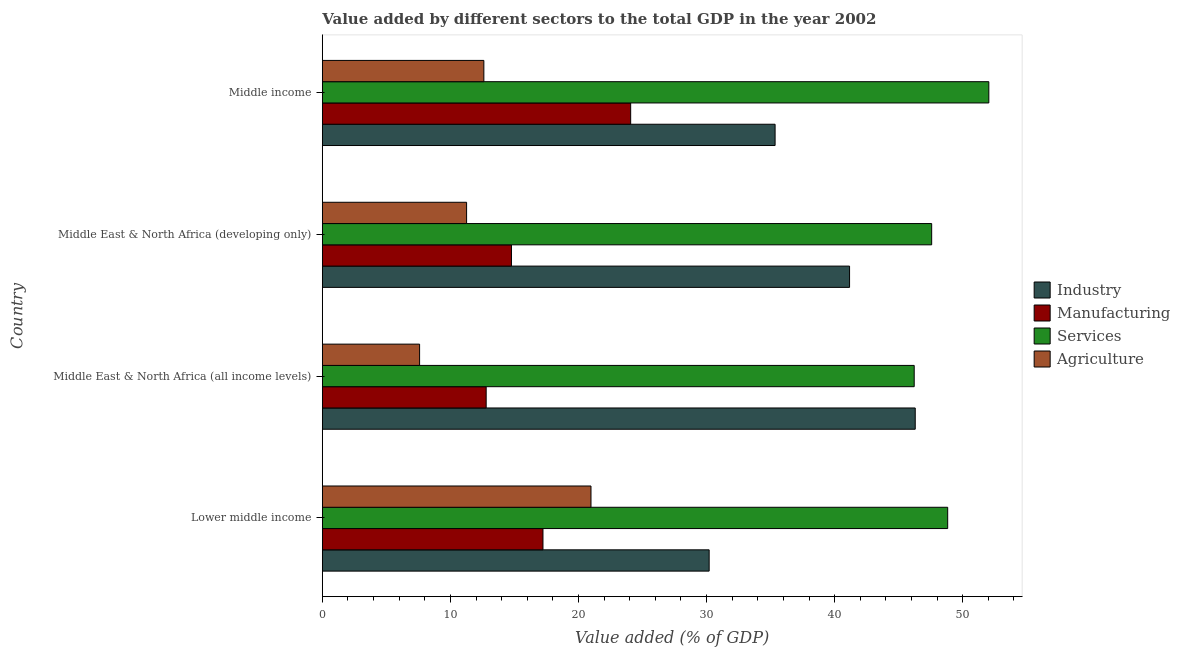How many different coloured bars are there?
Your answer should be very brief. 4. Are the number of bars per tick equal to the number of legend labels?
Offer a terse response. Yes. Are the number of bars on each tick of the Y-axis equal?
Offer a terse response. Yes. What is the label of the 4th group of bars from the top?
Ensure brevity in your answer.  Lower middle income. What is the value added by services sector in Middle income?
Offer a very short reply. 52.04. Across all countries, what is the maximum value added by agricultural sector?
Provide a short and direct response. 20.98. Across all countries, what is the minimum value added by industrial sector?
Provide a succinct answer. 30.2. In which country was the value added by agricultural sector maximum?
Offer a very short reply. Lower middle income. In which country was the value added by services sector minimum?
Keep it short and to the point. Middle East & North Africa (all income levels). What is the total value added by agricultural sector in the graph?
Your answer should be very brief. 52.44. What is the difference between the value added by agricultural sector in Lower middle income and that in Middle East & North Africa (developing only)?
Offer a terse response. 9.71. What is the difference between the value added by industrial sector in Middle East & North Africa (all income levels) and the value added by services sector in Lower middle income?
Make the answer very short. -2.53. What is the average value added by manufacturing sector per country?
Ensure brevity in your answer.  17.21. What is the difference between the value added by industrial sector and value added by services sector in Middle income?
Make the answer very short. -16.69. What is the ratio of the value added by services sector in Middle East & North Africa (all income levels) to that in Middle income?
Your answer should be compact. 0.89. What is the difference between the highest and the second highest value added by services sector?
Your answer should be compact. 3.21. What is the difference between the highest and the lowest value added by industrial sector?
Provide a succinct answer. 16.09. In how many countries, is the value added by manufacturing sector greater than the average value added by manufacturing sector taken over all countries?
Give a very brief answer. 2. Is the sum of the value added by agricultural sector in Middle East & North Africa (all income levels) and Middle income greater than the maximum value added by industrial sector across all countries?
Make the answer very short. No. Is it the case that in every country, the sum of the value added by manufacturing sector and value added by agricultural sector is greater than the sum of value added by industrial sector and value added by services sector?
Provide a succinct answer. No. What does the 2nd bar from the top in Middle East & North Africa (developing only) represents?
Ensure brevity in your answer.  Services. What does the 3rd bar from the bottom in Middle income represents?
Make the answer very short. Services. Is it the case that in every country, the sum of the value added by industrial sector and value added by manufacturing sector is greater than the value added by services sector?
Offer a very short reply. No. Does the graph contain any zero values?
Your answer should be compact. No. Does the graph contain grids?
Your response must be concise. No. Where does the legend appear in the graph?
Ensure brevity in your answer.  Center right. How many legend labels are there?
Keep it short and to the point. 4. What is the title of the graph?
Keep it short and to the point. Value added by different sectors to the total GDP in the year 2002. Does "Goods and services" appear as one of the legend labels in the graph?
Your answer should be very brief. No. What is the label or title of the X-axis?
Offer a terse response. Value added (% of GDP). What is the label or title of the Y-axis?
Offer a terse response. Country. What is the Value added (% of GDP) of Industry in Lower middle income?
Provide a short and direct response. 30.2. What is the Value added (% of GDP) of Manufacturing in Lower middle income?
Provide a succinct answer. 17.23. What is the Value added (% of GDP) in Services in Lower middle income?
Offer a terse response. 48.82. What is the Value added (% of GDP) of Agriculture in Lower middle income?
Provide a succinct answer. 20.98. What is the Value added (% of GDP) of Industry in Middle East & North Africa (all income levels)?
Your response must be concise. 46.29. What is the Value added (% of GDP) of Manufacturing in Middle East & North Africa (all income levels)?
Provide a short and direct response. 12.79. What is the Value added (% of GDP) of Services in Middle East & North Africa (all income levels)?
Provide a short and direct response. 46.21. What is the Value added (% of GDP) of Agriculture in Middle East & North Africa (all income levels)?
Provide a succinct answer. 7.59. What is the Value added (% of GDP) of Industry in Middle East & North Africa (developing only)?
Give a very brief answer. 41.16. What is the Value added (% of GDP) in Manufacturing in Middle East & North Africa (developing only)?
Provide a short and direct response. 14.77. What is the Value added (% of GDP) of Services in Middle East & North Africa (developing only)?
Ensure brevity in your answer.  47.57. What is the Value added (% of GDP) in Agriculture in Middle East & North Africa (developing only)?
Offer a terse response. 11.26. What is the Value added (% of GDP) of Industry in Middle income?
Ensure brevity in your answer.  35.35. What is the Value added (% of GDP) of Manufacturing in Middle income?
Provide a succinct answer. 24.07. What is the Value added (% of GDP) of Services in Middle income?
Keep it short and to the point. 52.04. What is the Value added (% of GDP) of Agriculture in Middle income?
Make the answer very short. 12.61. Across all countries, what is the maximum Value added (% of GDP) in Industry?
Offer a terse response. 46.29. Across all countries, what is the maximum Value added (% of GDP) in Manufacturing?
Your answer should be compact. 24.07. Across all countries, what is the maximum Value added (% of GDP) of Services?
Offer a very short reply. 52.04. Across all countries, what is the maximum Value added (% of GDP) in Agriculture?
Keep it short and to the point. 20.98. Across all countries, what is the minimum Value added (% of GDP) of Industry?
Provide a short and direct response. 30.2. Across all countries, what is the minimum Value added (% of GDP) in Manufacturing?
Your response must be concise. 12.79. Across all countries, what is the minimum Value added (% of GDP) of Services?
Make the answer very short. 46.21. Across all countries, what is the minimum Value added (% of GDP) of Agriculture?
Give a very brief answer. 7.59. What is the total Value added (% of GDP) in Industry in the graph?
Offer a very short reply. 153. What is the total Value added (% of GDP) in Manufacturing in the graph?
Give a very brief answer. 68.86. What is the total Value added (% of GDP) of Services in the graph?
Your answer should be very brief. 194.64. What is the total Value added (% of GDP) of Agriculture in the graph?
Ensure brevity in your answer.  52.44. What is the difference between the Value added (% of GDP) in Industry in Lower middle income and that in Middle East & North Africa (all income levels)?
Ensure brevity in your answer.  -16.09. What is the difference between the Value added (% of GDP) in Manufacturing in Lower middle income and that in Middle East & North Africa (all income levels)?
Offer a very short reply. 4.43. What is the difference between the Value added (% of GDP) in Services in Lower middle income and that in Middle East & North Africa (all income levels)?
Your answer should be compact. 2.61. What is the difference between the Value added (% of GDP) of Agriculture in Lower middle income and that in Middle East & North Africa (all income levels)?
Your response must be concise. 13.38. What is the difference between the Value added (% of GDP) of Industry in Lower middle income and that in Middle East & North Africa (developing only)?
Your answer should be very brief. -10.96. What is the difference between the Value added (% of GDP) in Manufacturing in Lower middle income and that in Middle East & North Africa (developing only)?
Ensure brevity in your answer.  2.46. What is the difference between the Value added (% of GDP) in Services in Lower middle income and that in Middle East & North Africa (developing only)?
Keep it short and to the point. 1.25. What is the difference between the Value added (% of GDP) in Agriculture in Lower middle income and that in Middle East & North Africa (developing only)?
Give a very brief answer. 9.71. What is the difference between the Value added (% of GDP) in Industry in Lower middle income and that in Middle income?
Provide a short and direct response. -5.15. What is the difference between the Value added (% of GDP) in Manufacturing in Lower middle income and that in Middle income?
Make the answer very short. -6.85. What is the difference between the Value added (% of GDP) in Services in Lower middle income and that in Middle income?
Offer a terse response. -3.21. What is the difference between the Value added (% of GDP) of Agriculture in Lower middle income and that in Middle income?
Provide a succinct answer. 8.36. What is the difference between the Value added (% of GDP) in Industry in Middle East & North Africa (all income levels) and that in Middle East & North Africa (developing only)?
Your response must be concise. 5.13. What is the difference between the Value added (% of GDP) of Manufacturing in Middle East & North Africa (all income levels) and that in Middle East & North Africa (developing only)?
Your answer should be very brief. -1.98. What is the difference between the Value added (% of GDP) in Services in Middle East & North Africa (all income levels) and that in Middle East & North Africa (developing only)?
Your answer should be compact. -1.36. What is the difference between the Value added (% of GDP) of Agriculture in Middle East & North Africa (all income levels) and that in Middle East & North Africa (developing only)?
Keep it short and to the point. -3.67. What is the difference between the Value added (% of GDP) of Industry in Middle East & North Africa (all income levels) and that in Middle income?
Offer a terse response. 10.94. What is the difference between the Value added (% of GDP) of Manufacturing in Middle East & North Africa (all income levels) and that in Middle income?
Ensure brevity in your answer.  -11.28. What is the difference between the Value added (% of GDP) in Services in Middle East & North Africa (all income levels) and that in Middle income?
Your response must be concise. -5.83. What is the difference between the Value added (% of GDP) in Agriculture in Middle East & North Africa (all income levels) and that in Middle income?
Your answer should be compact. -5.02. What is the difference between the Value added (% of GDP) of Industry in Middle East & North Africa (developing only) and that in Middle income?
Provide a succinct answer. 5.81. What is the difference between the Value added (% of GDP) in Manufacturing in Middle East & North Africa (developing only) and that in Middle income?
Make the answer very short. -9.31. What is the difference between the Value added (% of GDP) in Services in Middle East & North Africa (developing only) and that in Middle income?
Your answer should be compact. -4.46. What is the difference between the Value added (% of GDP) of Agriculture in Middle East & North Africa (developing only) and that in Middle income?
Ensure brevity in your answer.  -1.35. What is the difference between the Value added (% of GDP) in Industry in Lower middle income and the Value added (% of GDP) in Manufacturing in Middle East & North Africa (all income levels)?
Your response must be concise. 17.41. What is the difference between the Value added (% of GDP) of Industry in Lower middle income and the Value added (% of GDP) of Services in Middle East & North Africa (all income levels)?
Offer a terse response. -16.01. What is the difference between the Value added (% of GDP) in Industry in Lower middle income and the Value added (% of GDP) in Agriculture in Middle East & North Africa (all income levels)?
Your answer should be very brief. 22.61. What is the difference between the Value added (% of GDP) of Manufacturing in Lower middle income and the Value added (% of GDP) of Services in Middle East & North Africa (all income levels)?
Offer a terse response. -28.98. What is the difference between the Value added (% of GDP) of Manufacturing in Lower middle income and the Value added (% of GDP) of Agriculture in Middle East & North Africa (all income levels)?
Offer a very short reply. 9.63. What is the difference between the Value added (% of GDP) in Services in Lower middle income and the Value added (% of GDP) in Agriculture in Middle East & North Africa (all income levels)?
Provide a succinct answer. 41.23. What is the difference between the Value added (% of GDP) in Industry in Lower middle income and the Value added (% of GDP) in Manufacturing in Middle East & North Africa (developing only)?
Ensure brevity in your answer.  15.43. What is the difference between the Value added (% of GDP) of Industry in Lower middle income and the Value added (% of GDP) of Services in Middle East & North Africa (developing only)?
Provide a short and direct response. -17.37. What is the difference between the Value added (% of GDP) in Industry in Lower middle income and the Value added (% of GDP) in Agriculture in Middle East & North Africa (developing only)?
Your answer should be very brief. 18.94. What is the difference between the Value added (% of GDP) in Manufacturing in Lower middle income and the Value added (% of GDP) in Services in Middle East & North Africa (developing only)?
Offer a very short reply. -30.35. What is the difference between the Value added (% of GDP) in Manufacturing in Lower middle income and the Value added (% of GDP) in Agriculture in Middle East & North Africa (developing only)?
Make the answer very short. 5.96. What is the difference between the Value added (% of GDP) in Services in Lower middle income and the Value added (% of GDP) in Agriculture in Middle East & North Africa (developing only)?
Provide a short and direct response. 37.56. What is the difference between the Value added (% of GDP) of Industry in Lower middle income and the Value added (% of GDP) of Manufacturing in Middle income?
Ensure brevity in your answer.  6.13. What is the difference between the Value added (% of GDP) in Industry in Lower middle income and the Value added (% of GDP) in Services in Middle income?
Provide a succinct answer. -21.83. What is the difference between the Value added (% of GDP) of Industry in Lower middle income and the Value added (% of GDP) of Agriculture in Middle income?
Your answer should be compact. 17.59. What is the difference between the Value added (% of GDP) of Manufacturing in Lower middle income and the Value added (% of GDP) of Services in Middle income?
Ensure brevity in your answer.  -34.81. What is the difference between the Value added (% of GDP) in Manufacturing in Lower middle income and the Value added (% of GDP) in Agriculture in Middle income?
Provide a succinct answer. 4.61. What is the difference between the Value added (% of GDP) of Services in Lower middle income and the Value added (% of GDP) of Agriculture in Middle income?
Provide a succinct answer. 36.21. What is the difference between the Value added (% of GDP) in Industry in Middle East & North Africa (all income levels) and the Value added (% of GDP) in Manufacturing in Middle East & North Africa (developing only)?
Give a very brief answer. 31.52. What is the difference between the Value added (% of GDP) in Industry in Middle East & North Africa (all income levels) and the Value added (% of GDP) in Services in Middle East & North Africa (developing only)?
Your response must be concise. -1.28. What is the difference between the Value added (% of GDP) of Industry in Middle East & North Africa (all income levels) and the Value added (% of GDP) of Agriculture in Middle East & North Africa (developing only)?
Your answer should be very brief. 35.03. What is the difference between the Value added (% of GDP) in Manufacturing in Middle East & North Africa (all income levels) and the Value added (% of GDP) in Services in Middle East & North Africa (developing only)?
Give a very brief answer. -34.78. What is the difference between the Value added (% of GDP) in Manufacturing in Middle East & North Africa (all income levels) and the Value added (% of GDP) in Agriculture in Middle East & North Africa (developing only)?
Your answer should be compact. 1.53. What is the difference between the Value added (% of GDP) of Services in Middle East & North Africa (all income levels) and the Value added (% of GDP) of Agriculture in Middle East & North Africa (developing only)?
Offer a terse response. 34.95. What is the difference between the Value added (% of GDP) in Industry in Middle East & North Africa (all income levels) and the Value added (% of GDP) in Manufacturing in Middle income?
Make the answer very short. 22.22. What is the difference between the Value added (% of GDP) in Industry in Middle East & North Africa (all income levels) and the Value added (% of GDP) in Services in Middle income?
Offer a terse response. -5.75. What is the difference between the Value added (% of GDP) in Industry in Middle East & North Africa (all income levels) and the Value added (% of GDP) in Agriculture in Middle income?
Make the answer very short. 33.68. What is the difference between the Value added (% of GDP) in Manufacturing in Middle East & North Africa (all income levels) and the Value added (% of GDP) in Services in Middle income?
Make the answer very short. -39.24. What is the difference between the Value added (% of GDP) of Manufacturing in Middle East & North Africa (all income levels) and the Value added (% of GDP) of Agriculture in Middle income?
Provide a short and direct response. 0.18. What is the difference between the Value added (% of GDP) in Services in Middle East & North Africa (all income levels) and the Value added (% of GDP) in Agriculture in Middle income?
Your response must be concise. 33.6. What is the difference between the Value added (% of GDP) in Industry in Middle East & North Africa (developing only) and the Value added (% of GDP) in Manufacturing in Middle income?
Provide a short and direct response. 17.09. What is the difference between the Value added (% of GDP) of Industry in Middle East & North Africa (developing only) and the Value added (% of GDP) of Services in Middle income?
Ensure brevity in your answer.  -10.87. What is the difference between the Value added (% of GDP) in Industry in Middle East & North Africa (developing only) and the Value added (% of GDP) in Agriculture in Middle income?
Provide a succinct answer. 28.55. What is the difference between the Value added (% of GDP) of Manufacturing in Middle East & North Africa (developing only) and the Value added (% of GDP) of Services in Middle income?
Your response must be concise. -37.27. What is the difference between the Value added (% of GDP) in Manufacturing in Middle East & North Africa (developing only) and the Value added (% of GDP) in Agriculture in Middle income?
Offer a very short reply. 2.16. What is the difference between the Value added (% of GDP) of Services in Middle East & North Africa (developing only) and the Value added (% of GDP) of Agriculture in Middle income?
Offer a very short reply. 34.96. What is the average Value added (% of GDP) of Industry per country?
Offer a terse response. 38.25. What is the average Value added (% of GDP) of Manufacturing per country?
Keep it short and to the point. 17.21. What is the average Value added (% of GDP) of Services per country?
Provide a succinct answer. 48.66. What is the average Value added (% of GDP) of Agriculture per country?
Keep it short and to the point. 13.11. What is the difference between the Value added (% of GDP) in Industry and Value added (% of GDP) in Manufacturing in Lower middle income?
Your answer should be very brief. 12.97. What is the difference between the Value added (% of GDP) of Industry and Value added (% of GDP) of Services in Lower middle income?
Make the answer very short. -18.62. What is the difference between the Value added (% of GDP) of Industry and Value added (% of GDP) of Agriculture in Lower middle income?
Offer a very short reply. 9.23. What is the difference between the Value added (% of GDP) in Manufacturing and Value added (% of GDP) in Services in Lower middle income?
Offer a terse response. -31.6. What is the difference between the Value added (% of GDP) of Manufacturing and Value added (% of GDP) of Agriculture in Lower middle income?
Keep it short and to the point. -3.75. What is the difference between the Value added (% of GDP) of Services and Value added (% of GDP) of Agriculture in Lower middle income?
Offer a terse response. 27.85. What is the difference between the Value added (% of GDP) in Industry and Value added (% of GDP) in Manufacturing in Middle East & North Africa (all income levels)?
Make the answer very short. 33.5. What is the difference between the Value added (% of GDP) of Industry and Value added (% of GDP) of Services in Middle East & North Africa (all income levels)?
Offer a terse response. 0.08. What is the difference between the Value added (% of GDP) in Industry and Value added (% of GDP) in Agriculture in Middle East & North Africa (all income levels)?
Offer a very short reply. 38.7. What is the difference between the Value added (% of GDP) in Manufacturing and Value added (% of GDP) in Services in Middle East & North Africa (all income levels)?
Your answer should be compact. -33.42. What is the difference between the Value added (% of GDP) of Manufacturing and Value added (% of GDP) of Agriculture in Middle East & North Africa (all income levels)?
Your answer should be compact. 5.2. What is the difference between the Value added (% of GDP) in Services and Value added (% of GDP) in Agriculture in Middle East & North Africa (all income levels)?
Offer a very short reply. 38.62. What is the difference between the Value added (% of GDP) in Industry and Value added (% of GDP) in Manufacturing in Middle East & North Africa (developing only)?
Make the answer very short. 26.4. What is the difference between the Value added (% of GDP) in Industry and Value added (% of GDP) in Services in Middle East & North Africa (developing only)?
Make the answer very short. -6.41. What is the difference between the Value added (% of GDP) in Industry and Value added (% of GDP) in Agriculture in Middle East & North Africa (developing only)?
Offer a very short reply. 29.9. What is the difference between the Value added (% of GDP) of Manufacturing and Value added (% of GDP) of Services in Middle East & North Africa (developing only)?
Provide a short and direct response. -32.81. What is the difference between the Value added (% of GDP) in Manufacturing and Value added (% of GDP) in Agriculture in Middle East & North Africa (developing only)?
Offer a very short reply. 3.5. What is the difference between the Value added (% of GDP) of Services and Value added (% of GDP) of Agriculture in Middle East & North Africa (developing only)?
Give a very brief answer. 36.31. What is the difference between the Value added (% of GDP) in Industry and Value added (% of GDP) in Manufacturing in Middle income?
Ensure brevity in your answer.  11.28. What is the difference between the Value added (% of GDP) of Industry and Value added (% of GDP) of Services in Middle income?
Your answer should be compact. -16.69. What is the difference between the Value added (% of GDP) in Industry and Value added (% of GDP) in Agriculture in Middle income?
Your response must be concise. 22.74. What is the difference between the Value added (% of GDP) in Manufacturing and Value added (% of GDP) in Services in Middle income?
Keep it short and to the point. -27.96. What is the difference between the Value added (% of GDP) of Manufacturing and Value added (% of GDP) of Agriculture in Middle income?
Provide a succinct answer. 11.46. What is the difference between the Value added (% of GDP) of Services and Value added (% of GDP) of Agriculture in Middle income?
Your response must be concise. 39.42. What is the ratio of the Value added (% of GDP) in Industry in Lower middle income to that in Middle East & North Africa (all income levels)?
Your response must be concise. 0.65. What is the ratio of the Value added (% of GDP) in Manufacturing in Lower middle income to that in Middle East & North Africa (all income levels)?
Your answer should be very brief. 1.35. What is the ratio of the Value added (% of GDP) in Services in Lower middle income to that in Middle East & North Africa (all income levels)?
Keep it short and to the point. 1.06. What is the ratio of the Value added (% of GDP) in Agriculture in Lower middle income to that in Middle East & North Africa (all income levels)?
Keep it short and to the point. 2.76. What is the ratio of the Value added (% of GDP) in Industry in Lower middle income to that in Middle East & North Africa (developing only)?
Provide a succinct answer. 0.73. What is the ratio of the Value added (% of GDP) of Manufacturing in Lower middle income to that in Middle East & North Africa (developing only)?
Provide a short and direct response. 1.17. What is the ratio of the Value added (% of GDP) of Services in Lower middle income to that in Middle East & North Africa (developing only)?
Ensure brevity in your answer.  1.03. What is the ratio of the Value added (% of GDP) of Agriculture in Lower middle income to that in Middle East & North Africa (developing only)?
Your answer should be compact. 1.86. What is the ratio of the Value added (% of GDP) of Industry in Lower middle income to that in Middle income?
Keep it short and to the point. 0.85. What is the ratio of the Value added (% of GDP) of Manufacturing in Lower middle income to that in Middle income?
Make the answer very short. 0.72. What is the ratio of the Value added (% of GDP) in Services in Lower middle income to that in Middle income?
Ensure brevity in your answer.  0.94. What is the ratio of the Value added (% of GDP) of Agriculture in Lower middle income to that in Middle income?
Keep it short and to the point. 1.66. What is the ratio of the Value added (% of GDP) of Industry in Middle East & North Africa (all income levels) to that in Middle East & North Africa (developing only)?
Give a very brief answer. 1.12. What is the ratio of the Value added (% of GDP) of Manufacturing in Middle East & North Africa (all income levels) to that in Middle East & North Africa (developing only)?
Your answer should be very brief. 0.87. What is the ratio of the Value added (% of GDP) in Services in Middle East & North Africa (all income levels) to that in Middle East & North Africa (developing only)?
Offer a very short reply. 0.97. What is the ratio of the Value added (% of GDP) in Agriculture in Middle East & North Africa (all income levels) to that in Middle East & North Africa (developing only)?
Offer a terse response. 0.67. What is the ratio of the Value added (% of GDP) in Industry in Middle East & North Africa (all income levels) to that in Middle income?
Offer a terse response. 1.31. What is the ratio of the Value added (% of GDP) of Manufacturing in Middle East & North Africa (all income levels) to that in Middle income?
Provide a short and direct response. 0.53. What is the ratio of the Value added (% of GDP) of Services in Middle East & North Africa (all income levels) to that in Middle income?
Your answer should be compact. 0.89. What is the ratio of the Value added (% of GDP) in Agriculture in Middle East & North Africa (all income levels) to that in Middle income?
Your answer should be very brief. 0.6. What is the ratio of the Value added (% of GDP) of Industry in Middle East & North Africa (developing only) to that in Middle income?
Offer a very short reply. 1.16. What is the ratio of the Value added (% of GDP) in Manufacturing in Middle East & North Africa (developing only) to that in Middle income?
Provide a short and direct response. 0.61. What is the ratio of the Value added (% of GDP) in Services in Middle East & North Africa (developing only) to that in Middle income?
Ensure brevity in your answer.  0.91. What is the ratio of the Value added (% of GDP) of Agriculture in Middle East & North Africa (developing only) to that in Middle income?
Offer a very short reply. 0.89. What is the difference between the highest and the second highest Value added (% of GDP) in Industry?
Your answer should be very brief. 5.13. What is the difference between the highest and the second highest Value added (% of GDP) in Manufacturing?
Offer a terse response. 6.85. What is the difference between the highest and the second highest Value added (% of GDP) in Services?
Offer a very short reply. 3.21. What is the difference between the highest and the second highest Value added (% of GDP) in Agriculture?
Give a very brief answer. 8.36. What is the difference between the highest and the lowest Value added (% of GDP) of Industry?
Your response must be concise. 16.09. What is the difference between the highest and the lowest Value added (% of GDP) in Manufacturing?
Ensure brevity in your answer.  11.28. What is the difference between the highest and the lowest Value added (% of GDP) in Services?
Make the answer very short. 5.83. What is the difference between the highest and the lowest Value added (% of GDP) in Agriculture?
Keep it short and to the point. 13.38. 